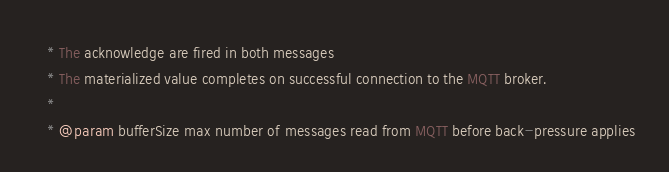Convert code to text. <code><loc_0><loc_0><loc_500><loc_500><_Scala_>   * The acknowledge are fired in both messages
   * The materialized value completes on successful connection to the MQTT broker.
   *
   * @param bufferSize max number of messages read from MQTT before back-pressure applies</code> 